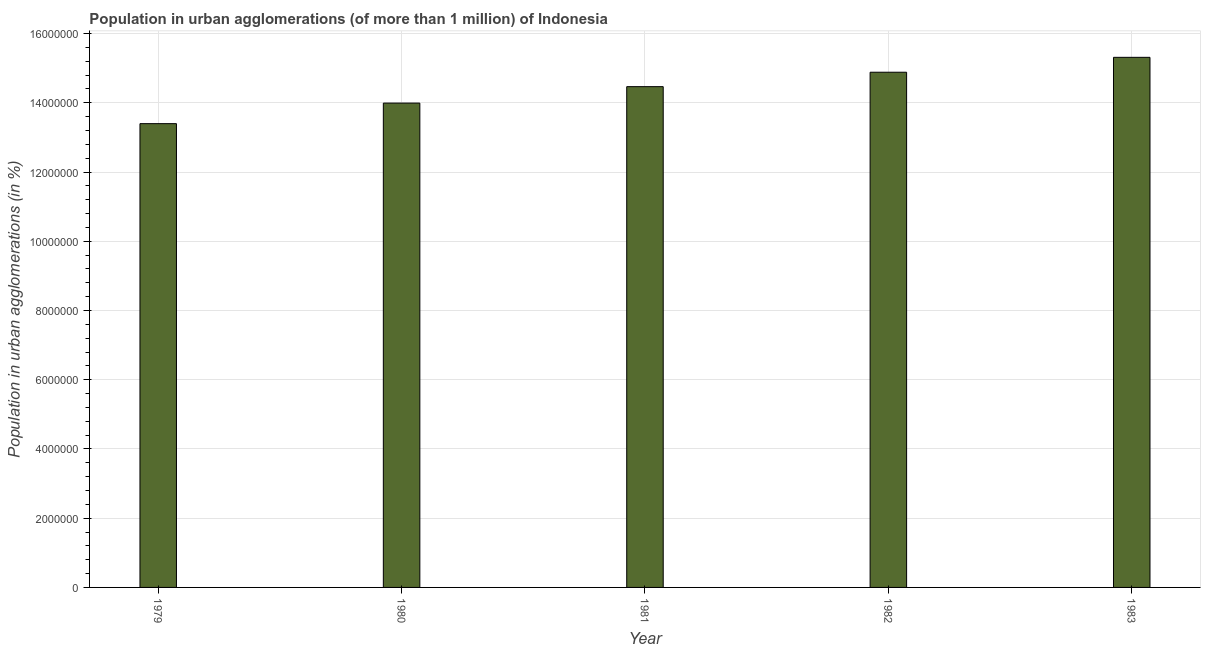Does the graph contain any zero values?
Your response must be concise. No. Does the graph contain grids?
Your answer should be compact. Yes. What is the title of the graph?
Your answer should be very brief. Population in urban agglomerations (of more than 1 million) of Indonesia. What is the label or title of the X-axis?
Your answer should be compact. Year. What is the label or title of the Y-axis?
Provide a succinct answer. Population in urban agglomerations (in %). What is the population in urban agglomerations in 1980?
Your response must be concise. 1.40e+07. Across all years, what is the maximum population in urban agglomerations?
Your answer should be very brief. 1.53e+07. Across all years, what is the minimum population in urban agglomerations?
Your answer should be compact. 1.34e+07. In which year was the population in urban agglomerations maximum?
Ensure brevity in your answer.  1983. In which year was the population in urban agglomerations minimum?
Offer a terse response. 1979. What is the sum of the population in urban agglomerations?
Make the answer very short. 7.21e+07. What is the difference between the population in urban agglomerations in 1979 and 1981?
Provide a succinct answer. -1.07e+06. What is the average population in urban agglomerations per year?
Ensure brevity in your answer.  1.44e+07. What is the median population in urban agglomerations?
Your answer should be very brief. 1.45e+07. In how many years, is the population in urban agglomerations greater than 13600000 %?
Provide a short and direct response. 4. Is the difference between the population in urban agglomerations in 1980 and 1981 greater than the difference between any two years?
Provide a short and direct response. No. What is the difference between the highest and the second highest population in urban agglomerations?
Offer a very short reply. 4.30e+05. What is the difference between the highest and the lowest population in urban agglomerations?
Your answer should be very brief. 1.92e+06. How many bars are there?
Ensure brevity in your answer.  5. Are all the bars in the graph horizontal?
Make the answer very short. No. What is the difference between two consecutive major ticks on the Y-axis?
Provide a short and direct response. 2.00e+06. What is the Population in urban agglomerations (in %) of 1979?
Keep it short and to the point. 1.34e+07. What is the Population in urban agglomerations (in %) in 1980?
Provide a short and direct response. 1.40e+07. What is the Population in urban agglomerations (in %) in 1981?
Give a very brief answer. 1.45e+07. What is the Population in urban agglomerations (in %) in 1982?
Your answer should be compact. 1.49e+07. What is the Population in urban agglomerations (in %) in 1983?
Your answer should be compact. 1.53e+07. What is the difference between the Population in urban agglomerations (in %) in 1979 and 1980?
Provide a short and direct response. -5.94e+05. What is the difference between the Population in urban agglomerations (in %) in 1979 and 1981?
Offer a terse response. -1.07e+06. What is the difference between the Population in urban agglomerations (in %) in 1979 and 1982?
Provide a short and direct response. -1.49e+06. What is the difference between the Population in urban agglomerations (in %) in 1979 and 1983?
Your answer should be very brief. -1.92e+06. What is the difference between the Population in urban agglomerations (in %) in 1980 and 1981?
Keep it short and to the point. -4.75e+05. What is the difference between the Population in urban agglomerations (in %) in 1980 and 1982?
Make the answer very short. -8.92e+05. What is the difference between the Population in urban agglomerations (in %) in 1980 and 1983?
Give a very brief answer. -1.32e+06. What is the difference between the Population in urban agglomerations (in %) in 1981 and 1982?
Offer a very short reply. -4.17e+05. What is the difference between the Population in urban agglomerations (in %) in 1981 and 1983?
Provide a succinct answer. -8.47e+05. What is the difference between the Population in urban agglomerations (in %) in 1982 and 1983?
Your answer should be very brief. -4.30e+05. What is the ratio of the Population in urban agglomerations (in %) in 1979 to that in 1980?
Your answer should be compact. 0.96. What is the ratio of the Population in urban agglomerations (in %) in 1979 to that in 1981?
Your response must be concise. 0.93. What is the ratio of the Population in urban agglomerations (in %) in 1979 to that in 1982?
Provide a succinct answer. 0.9. What is the ratio of the Population in urban agglomerations (in %) in 1980 to that in 1981?
Provide a succinct answer. 0.97. What is the ratio of the Population in urban agglomerations (in %) in 1980 to that in 1983?
Provide a short and direct response. 0.91. What is the ratio of the Population in urban agglomerations (in %) in 1981 to that in 1983?
Make the answer very short. 0.94. 